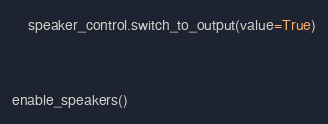<code> <loc_0><loc_0><loc_500><loc_500><_Python_>    speaker_control.switch_to_output(value=True)


enable_speakers()
</code> 